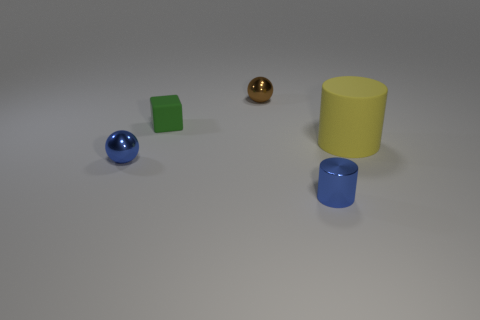How many tiny yellow cubes are there?
Your answer should be very brief. 0. How many things are tiny green rubber cubes or metal things behind the large rubber cylinder?
Your response must be concise. 2. Are there any other things that have the same shape as the tiny green object?
Offer a very short reply. No. There is a metal thing behind the blue sphere; is its size the same as the tiny cube?
Offer a terse response. Yes. How many metal things are tiny blue cylinders or large spheres?
Your answer should be compact. 1. There is a cylinder behind the tiny blue ball; how big is it?
Ensure brevity in your answer.  Large. How many tiny objects are red rubber blocks or matte cylinders?
Offer a very short reply. 0. Are there any large things to the right of the small blue cylinder?
Ensure brevity in your answer.  Yes. Is the number of tiny brown metal balls that are right of the brown shiny sphere the same as the number of blue cylinders?
Give a very brief answer. No. There is a yellow rubber object; is its shape the same as the tiny blue thing that is on the right side of the matte block?
Offer a terse response. Yes. 